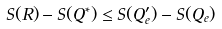<formula> <loc_0><loc_0><loc_500><loc_500>S ( R ) - S ( Q ^ { * } ) \leq S ( Q _ { e } ^ { \prime } ) - S ( Q _ { e } )</formula> 